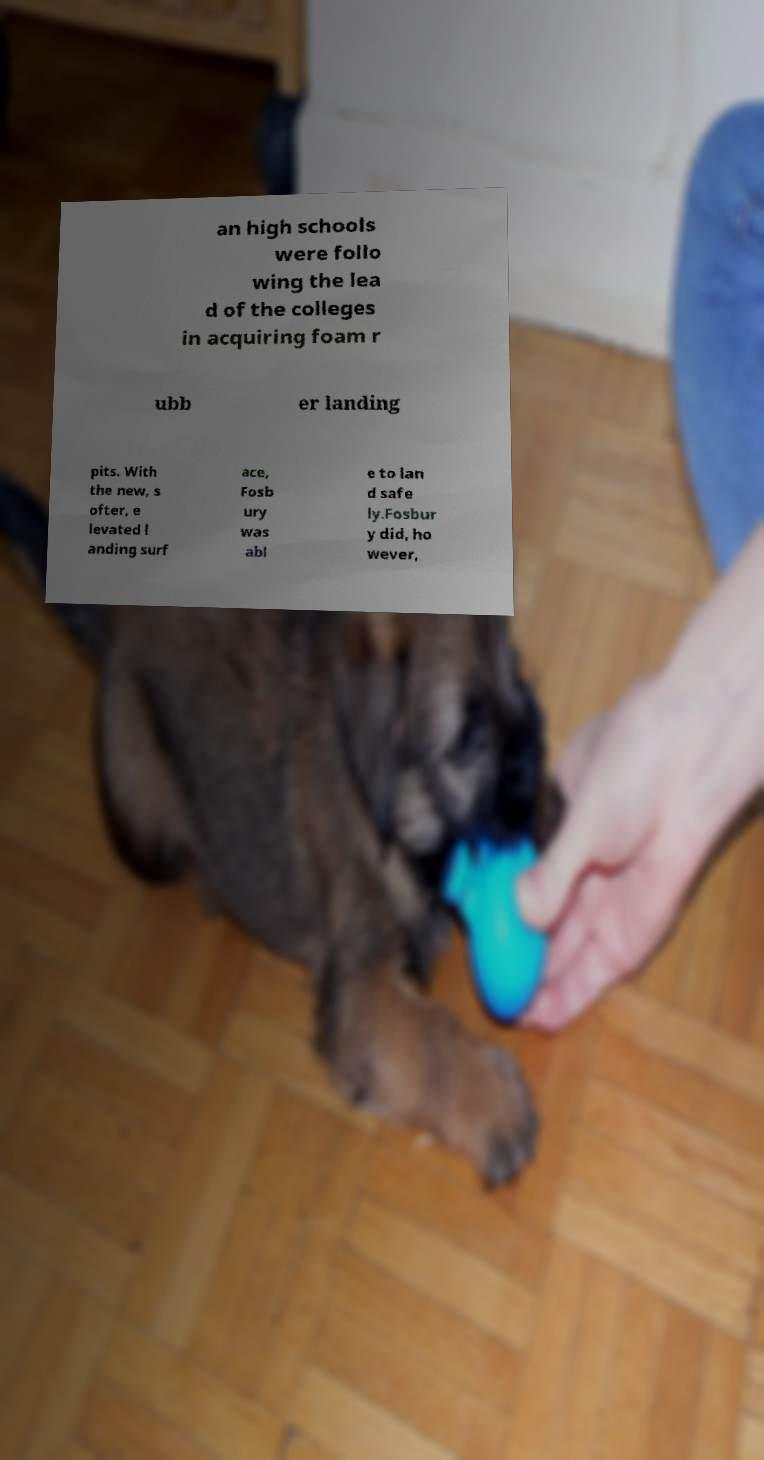Can you accurately transcribe the text from the provided image for me? an high schools were follo wing the lea d of the colleges in acquiring foam r ubb er landing pits. With the new, s ofter, e levated l anding surf ace, Fosb ury was abl e to lan d safe ly.Fosbur y did, ho wever, 